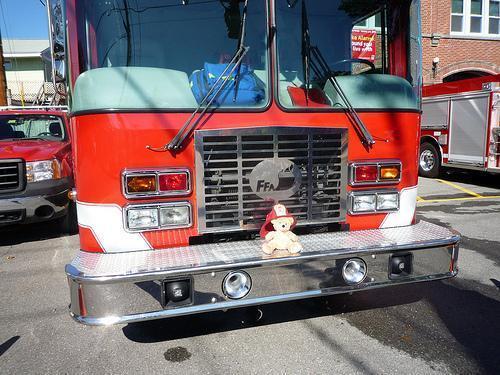How many bears are there?
Give a very brief answer. 1. How many windshield wipers are there?
Give a very brief answer. 2. 